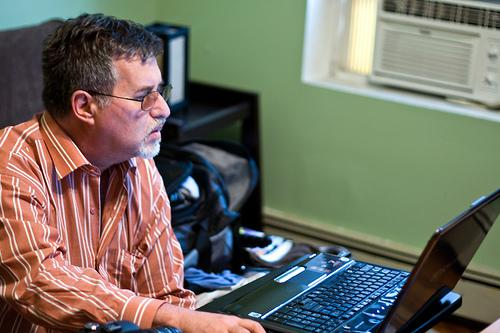Question: what pattern is on the man's shirt?
Choices:
A. Plaid.
B. Stripes.
C. Print.
D. Solid.
Answer with the letter. Answer: B Question: what color is the wall?
Choices:
A. Green.
B. Blue.
C. White.
D. Beige.
Answer with the letter. Answer: A Question: why is the man wearing glasses?
Choices:
A. To drive.
B. To read.
C. To block sun.
D. To see.
Answer with the letter. Answer: D 